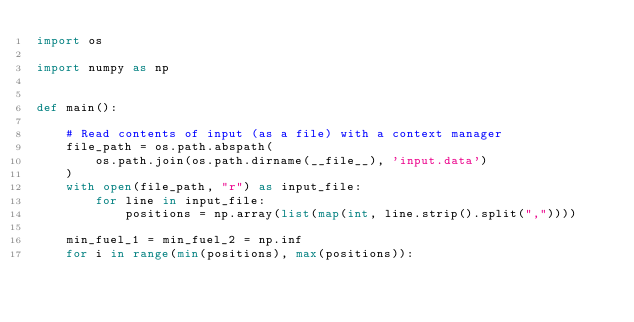Convert code to text. <code><loc_0><loc_0><loc_500><loc_500><_Python_>import os

import numpy as np


def main():

    # Read contents of input (as a file) with a context manager
    file_path = os.path.abspath(
        os.path.join(os.path.dirname(__file__), 'input.data')
    )
    with open(file_path, "r") as input_file:
        for line in input_file:
            positions = np.array(list(map(int, line.strip().split(","))))

    min_fuel_1 = min_fuel_2 = np.inf
    for i in range(min(positions), max(positions)):</code> 